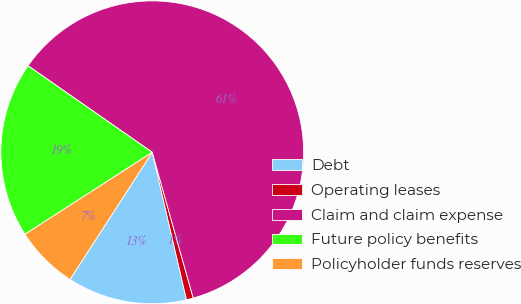<chart> <loc_0><loc_0><loc_500><loc_500><pie_chart><fcel>Debt<fcel>Operating leases<fcel>Claim and claim expense<fcel>Future policy benefits<fcel>Policyholder funds reserves<nl><fcel>12.77%<fcel>0.73%<fcel>60.96%<fcel>18.8%<fcel>6.75%<nl></chart> 